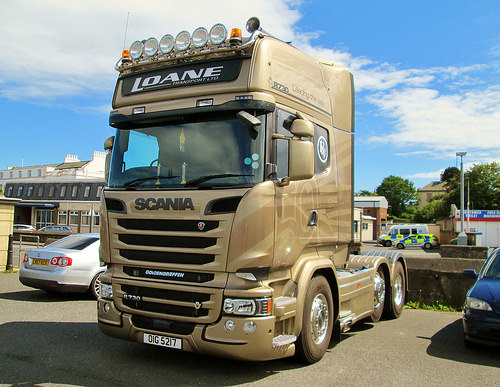<image>
Is the bright lights above the chrome? Yes. The bright lights is positioned above the chrome in the vertical space, higher up in the scene. 